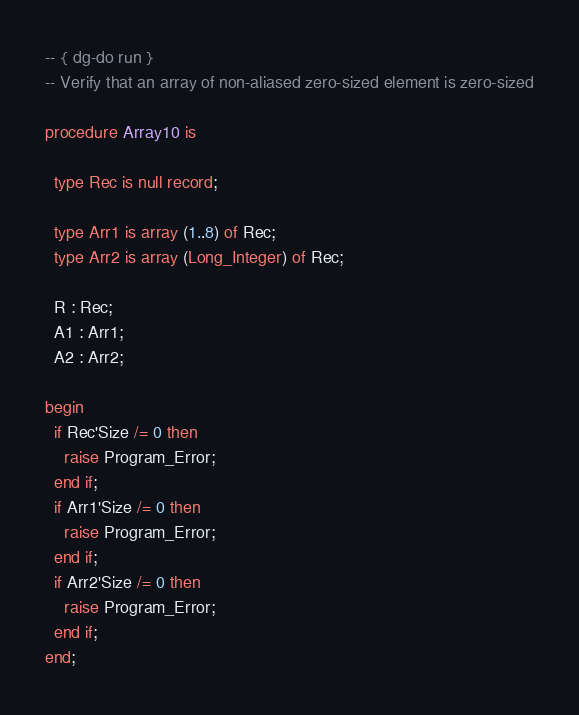<code> <loc_0><loc_0><loc_500><loc_500><_Ada_>-- { dg-do run }
-- Verify that an array of non-aliased zero-sized element is zero-sized

procedure Array10 is

  type Rec is null record;

  type Arr1 is array (1..8) of Rec;
  type Arr2 is array (Long_Integer) of Rec;

  R : Rec;
  A1 : Arr1;
  A2 : Arr2;

begin
  if Rec'Size /= 0 then
    raise Program_Error;
  end if;
  if Arr1'Size /= 0 then
    raise Program_Error;
  end if;
  if Arr2'Size /= 0 then
    raise Program_Error;
  end if;
end;
</code> 